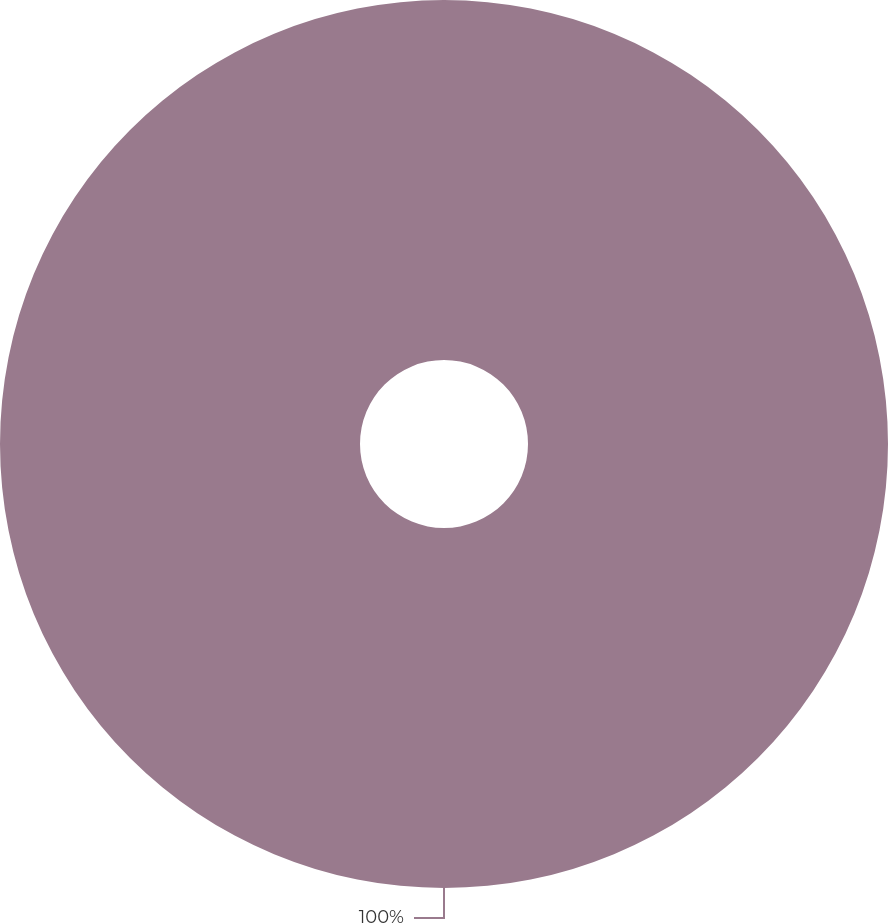<chart> <loc_0><loc_0><loc_500><loc_500><pie_chart><ecel><nl><fcel>100.0%<nl></chart> 